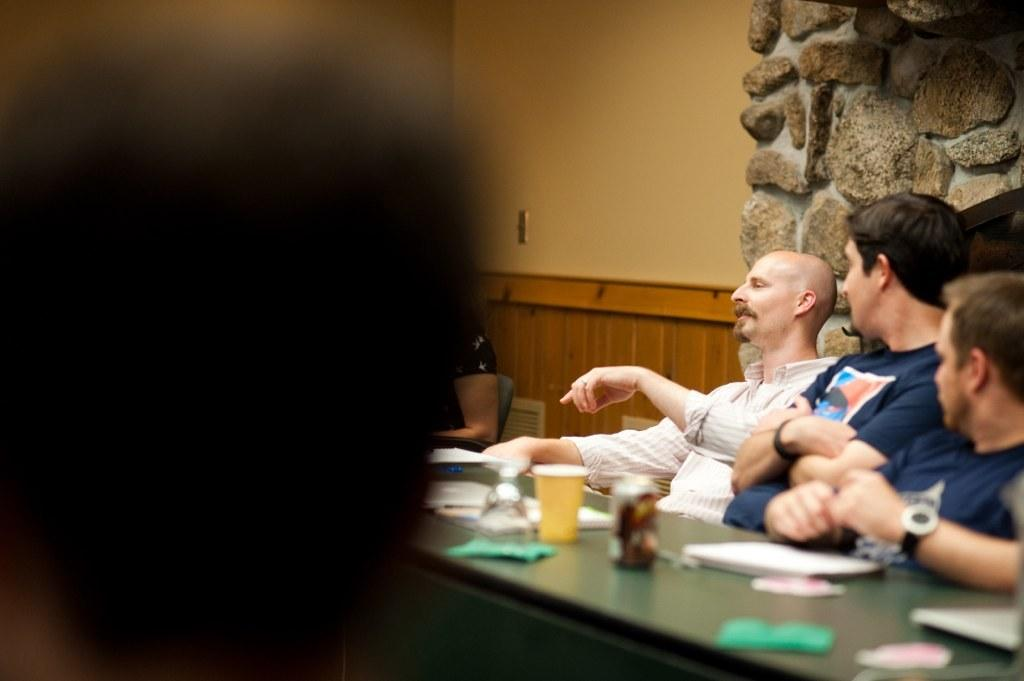What are the people in the image doing? The people in the image are sitting on chairs. What is on the table in the image? There are papers, a cup, and other objects on the table. Can you describe the background of the image? There is a rock wall in the background of the image. How many icicles are hanging from the rock wall in the image? There are no icicles present in the image; the background features a rock wall without any icicles. 